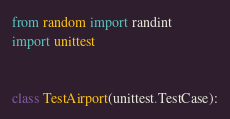Convert code to text. <code><loc_0><loc_0><loc_500><loc_500><_Python_>from random import randint
import unittest


class TestAirport(unittest.TestCase):</code> 